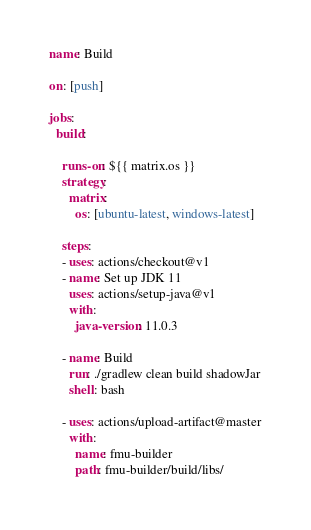<code> <loc_0><loc_0><loc_500><loc_500><_YAML_>name: Build

on: [push]

jobs:
  build:

    runs-on: ${{ matrix.os }}
    strategy:
      matrix:
        os: [ubuntu-latest, windows-latest]
    
    steps:
    - uses: actions/checkout@v1
    - name: Set up JDK 11
      uses: actions/setup-java@v1
      with:
        java-version: 11.0.3

    - name: Build
      run: ./gradlew clean build shadowJar
      shell: bash

    - uses: actions/upload-artifact@master
      with:
        name: fmu-builder
        path: fmu-builder/build/libs/
</code> 